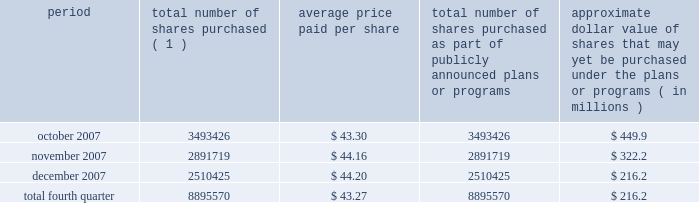Issuer purchases of equity securities during the three months ended december 31 , 2007 , we repurchased 8895570 shares of our class a common stock for an aggregate of $ 385.1 million pursuant to the $ 1.5 billion stock repurchase program publicly announced in february 2007 , as follows : period total number of shares purchased ( 1 ) average price paid per share total number of shares purchased as part of publicly announced plans or programs approximate dollar value of shares that may yet be purchased under the plans or programs ( in millions ) .
( 1 ) issuer repurchases pursuant to the $ 1.5 billion stock repurchase program publicly announced in february 2007 .
Under this program , our management was authorized through february 2008 to purchase shares from time to time through open market purchases or privately negotiated transactions at prevailing prices as permitted by securities laws and other legal requirements , and subject to market conditions and other factors .
To facilitate repurchases , we typically made purchases pursuant to trading plans under rule 10b5-1 of the exchange act , which allow us to repurchase shares during periods when we otherwise might be prevented from doing so under insider trading laws or because of self-imposed trading blackout periods .
Subsequent to december 31 , 2007 , we repurchased 4.3 million shares of our class a common stock for an aggregate of $ 163.7 million pursuant to this program .
In february 2008 , our board of directors approved a new stock repurchase program , pursuant to which we are authorized to purchase up to an additional $ 1.5 billion of our class a common stock .
Purchases under this stock repurchase program are subject to us having available cash to fund repurchases , as further described in item 1a of this annual report under the caption 201crisk factors 2014we anticipate that we may need additional financing to fund our stock repurchase programs , to refinance our existing indebtedness and to fund future growth and expansion initiatives 201d and item 7 of this annual report under the caption 201cmanagement 2019s discussion and analysis of financial condition and results of operations 2014liquidity and capital resources . 201d .
What is the total amount spent for stock repurchase during november 2007 , in millions? 
Computations: ((2891719 * 44.16) / 1000000)
Answer: 127.69831. 